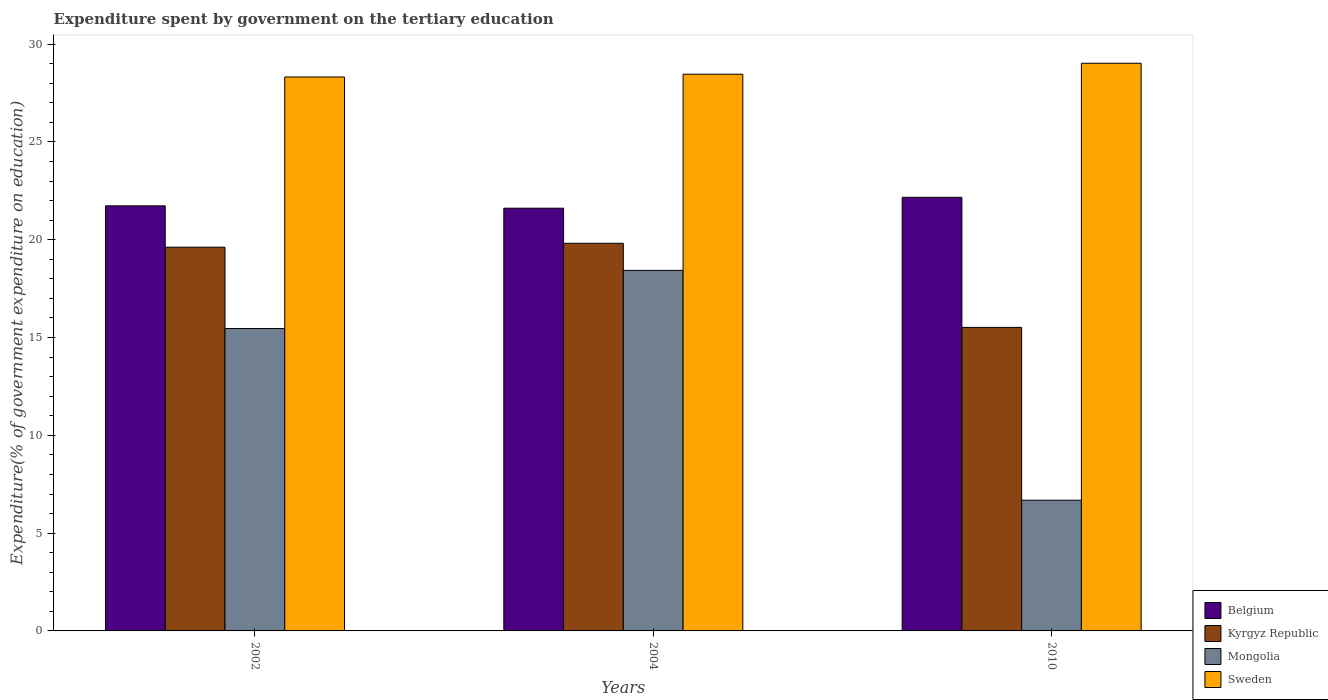How many groups of bars are there?
Give a very brief answer. 3. Are the number of bars per tick equal to the number of legend labels?
Offer a very short reply. Yes. How many bars are there on the 2nd tick from the left?
Provide a short and direct response. 4. How many bars are there on the 3rd tick from the right?
Your answer should be compact. 4. What is the label of the 3rd group of bars from the left?
Your response must be concise. 2010. What is the expenditure spent by government on the tertiary education in Mongolia in 2002?
Your answer should be compact. 15.46. Across all years, what is the maximum expenditure spent by government on the tertiary education in Sweden?
Provide a short and direct response. 29.02. Across all years, what is the minimum expenditure spent by government on the tertiary education in Kyrgyz Republic?
Make the answer very short. 15.52. In which year was the expenditure spent by government on the tertiary education in Mongolia maximum?
Provide a short and direct response. 2004. In which year was the expenditure spent by government on the tertiary education in Sweden minimum?
Ensure brevity in your answer.  2002. What is the total expenditure spent by government on the tertiary education in Belgium in the graph?
Your answer should be very brief. 65.51. What is the difference between the expenditure spent by government on the tertiary education in Belgium in 2002 and that in 2010?
Your answer should be very brief. -0.44. What is the difference between the expenditure spent by government on the tertiary education in Sweden in 2010 and the expenditure spent by government on the tertiary education in Kyrgyz Republic in 2004?
Keep it short and to the point. 9.2. What is the average expenditure spent by government on the tertiary education in Kyrgyz Republic per year?
Your response must be concise. 18.32. In the year 2004, what is the difference between the expenditure spent by government on the tertiary education in Belgium and expenditure spent by government on the tertiary education in Mongolia?
Make the answer very short. 3.18. What is the ratio of the expenditure spent by government on the tertiary education in Sweden in 2004 to that in 2010?
Provide a succinct answer. 0.98. Is the expenditure spent by government on the tertiary education in Sweden in 2002 less than that in 2004?
Give a very brief answer. Yes. Is the difference between the expenditure spent by government on the tertiary education in Belgium in 2002 and 2010 greater than the difference between the expenditure spent by government on the tertiary education in Mongolia in 2002 and 2010?
Provide a short and direct response. No. What is the difference between the highest and the second highest expenditure spent by government on the tertiary education in Belgium?
Keep it short and to the point. 0.44. What is the difference between the highest and the lowest expenditure spent by government on the tertiary education in Sweden?
Offer a terse response. 0.7. In how many years, is the expenditure spent by government on the tertiary education in Kyrgyz Republic greater than the average expenditure spent by government on the tertiary education in Kyrgyz Republic taken over all years?
Offer a very short reply. 2. Is it the case that in every year, the sum of the expenditure spent by government on the tertiary education in Belgium and expenditure spent by government on the tertiary education in Kyrgyz Republic is greater than the sum of expenditure spent by government on the tertiary education in Sweden and expenditure spent by government on the tertiary education in Mongolia?
Give a very brief answer. Yes. What does the 1st bar from the left in 2010 represents?
Offer a very short reply. Belgium. What does the 2nd bar from the right in 2004 represents?
Make the answer very short. Mongolia. Are all the bars in the graph horizontal?
Provide a short and direct response. No. How many years are there in the graph?
Your response must be concise. 3. Are the values on the major ticks of Y-axis written in scientific E-notation?
Your answer should be compact. No. Does the graph contain any zero values?
Your answer should be compact. No. What is the title of the graph?
Give a very brief answer. Expenditure spent by government on the tertiary education. Does "Aruba" appear as one of the legend labels in the graph?
Make the answer very short. No. What is the label or title of the Y-axis?
Your response must be concise. Expenditure(% of government expenditure on education). What is the Expenditure(% of government expenditure on education) of Belgium in 2002?
Make the answer very short. 21.73. What is the Expenditure(% of government expenditure on education) of Kyrgyz Republic in 2002?
Make the answer very short. 19.62. What is the Expenditure(% of government expenditure on education) of Mongolia in 2002?
Your response must be concise. 15.46. What is the Expenditure(% of government expenditure on education) in Sweden in 2002?
Offer a very short reply. 28.32. What is the Expenditure(% of government expenditure on education) of Belgium in 2004?
Give a very brief answer. 21.61. What is the Expenditure(% of government expenditure on education) of Kyrgyz Republic in 2004?
Provide a short and direct response. 19.82. What is the Expenditure(% of government expenditure on education) of Mongolia in 2004?
Keep it short and to the point. 18.43. What is the Expenditure(% of government expenditure on education) of Sweden in 2004?
Provide a succinct answer. 28.46. What is the Expenditure(% of government expenditure on education) in Belgium in 2010?
Offer a very short reply. 22.17. What is the Expenditure(% of government expenditure on education) of Kyrgyz Republic in 2010?
Offer a very short reply. 15.52. What is the Expenditure(% of government expenditure on education) in Mongolia in 2010?
Keep it short and to the point. 6.68. What is the Expenditure(% of government expenditure on education) of Sweden in 2010?
Make the answer very short. 29.02. Across all years, what is the maximum Expenditure(% of government expenditure on education) of Belgium?
Your answer should be very brief. 22.17. Across all years, what is the maximum Expenditure(% of government expenditure on education) in Kyrgyz Republic?
Make the answer very short. 19.82. Across all years, what is the maximum Expenditure(% of government expenditure on education) of Mongolia?
Keep it short and to the point. 18.43. Across all years, what is the maximum Expenditure(% of government expenditure on education) of Sweden?
Your answer should be very brief. 29.02. Across all years, what is the minimum Expenditure(% of government expenditure on education) of Belgium?
Keep it short and to the point. 21.61. Across all years, what is the minimum Expenditure(% of government expenditure on education) of Kyrgyz Republic?
Make the answer very short. 15.52. Across all years, what is the minimum Expenditure(% of government expenditure on education) of Mongolia?
Give a very brief answer. 6.68. Across all years, what is the minimum Expenditure(% of government expenditure on education) in Sweden?
Offer a very short reply. 28.32. What is the total Expenditure(% of government expenditure on education) of Belgium in the graph?
Keep it short and to the point. 65.51. What is the total Expenditure(% of government expenditure on education) of Kyrgyz Republic in the graph?
Your answer should be very brief. 54.95. What is the total Expenditure(% of government expenditure on education) in Mongolia in the graph?
Provide a short and direct response. 40.57. What is the total Expenditure(% of government expenditure on education) in Sweden in the graph?
Keep it short and to the point. 85.8. What is the difference between the Expenditure(% of government expenditure on education) of Belgium in 2002 and that in 2004?
Offer a terse response. 0.12. What is the difference between the Expenditure(% of government expenditure on education) of Kyrgyz Republic in 2002 and that in 2004?
Offer a terse response. -0.2. What is the difference between the Expenditure(% of government expenditure on education) in Mongolia in 2002 and that in 2004?
Keep it short and to the point. -2.97. What is the difference between the Expenditure(% of government expenditure on education) of Sweden in 2002 and that in 2004?
Provide a succinct answer. -0.14. What is the difference between the Expenditure(% of government expenditure on education) in Belgium in 2002 and that in 2010?
Keep it short and to the point. -0.44. What is the difference between the Expenditure(% of government expenditure on education) of Kyrgyz Republic in 2002 and that in 2010?
Ensure brevity in your answer.  4.1. What is the difference between the Expenditure(% of government expenditure on education) in Mongolia in 2002 and that in 2010?
Provide a succinct answer. 8.78. What is the difference between the Expenditure(% of government expenditure on education) in Sweden in 2002 and that in 2010?
Offer a terse response. -0.7. What is the difference between the Expenditure(% of government expenditure on education) in Belgium in 2004 and that in 2010?
Your response must be concise. -0.56. What is the difference between the Expenditure(% of government expenditure on education) in Kyrgyz Republic in 2004 and that in 2010?
Your answer should be very brief. 4.3. What is the difference between the Expenditure(% of government expenditure on education) in Mongolia in 2004 and that in 2010?
Offer a very short reply. 11.75. What is the difference between the Expenditure(% of government expenditure on education) in Sweden in 2004 and that in 2010?
Your answer should be very brief. -0.56. What is the difference between the Expenditure(% of government expenditure on education) in Belgium in 2002 and the Expenditure(% of government expenditure on education) in Kyrgyz Republic in 2004?
Provide a short and direct response. 1.91. What is the difference between the Expenditure(% of government expenditure on education) of Belgium in 2002 and the Expenditure(% of government expenditure on education) of Mongolia in 2004?
Provide a succinct answer. 3.3. What is the difference between the Expenditure(% of government expenditure on education) of Belgium in 2002 and the Expenditure(% of government expenditure on education) of Sweden in 2004?
Your answer should be very brief. -6.73. What is the difference between the Expenditure(% of government expenditure on education) in Kyrgyz Republic in 2002 and the Expenditure(% of government expenditure on education) in Mongolia in 2004?
Give a very brief answer. 1.19. What is the difference between the Expenditure(% of government expenditure on education) of Kyrgyz Republic in 2002 and the Expenditure(% of government expenditure on education) of Sweden in 2004?
Your answer should be compact. -8.84. What is the difference between the Expenditure(% of government expenditure on education) of Mongolia in 2002 and the Expenditure(% of government expenditure on education) of Sweden in 2004?
Offer a very short reply. -13. What is the difference between the Expenditure(% of government expenditure on education) in Belgium in 2002 and the Expenditure(% of government expenditure on education) in Kyrgyz Republic in 2010?
Your response must be concise. 6.21. What is the difference between the Expenditure(% of government expenditure on education) of Belgium in 2002 and the Expenditure(% of government expenditure on education) of Mongolia in 2010?
Your response must be concise. 15.05. What is the difference between the Expenditure(% of government expenditure on education) of Belgium in 2002 and the Expenditure(% of government expenditure on education) of Sweden in 2010?
Your answer should be very brief. -7.29. What is the difference between the Expenditure(% of government expenditure on education) of Kyrgyz Republic in 2002 and the Expenditure(% of government expenditure on education) of Mongolia in 2010?
Keep it short and to the point. 12.94. What is the difference between the Expenditure(% of government expenditure on education) of Kyrgyz Republic in 2002 and the Expenditure(% of government expenditure on education) of Sweden in 2010?
Give a very brief answer. -9.4. What is the difference between the Expenditure(% of government expenditure on education) in Mongolia in 2002 and the Expenditure(% of government expenditure on education) in Sweden in 2010?
Provide a succinct answer. -13.56. What is the difference between the Expenditure(% of government expenditure on education) of Belgium in 2004 and the Expenditure(% of government expenditure on education) of Kyrgyz Republic in 2010?
Make the answer very short. 6.1. What is the difference between the Expenditure(% of government expenditure on education) of Belgium in 2004 and the Expenditure(% of government expenditure on education) of Mongolia in 2010?
Offer a very short reply. 14.93. What is the difference between the Expenditure(% of government expenditure on education) in Belgium in 2004 and the Expenditure(% of government expenditure on education) in Sweden in 2010?
Give a very brief answer. -7.41. What is the difference between the Expenditure(% of government expenditure on education) of Kyrgyz Republic in 2004 and the Expenditure(% of government expenditure on education) of Mongolia in 2010?
Keep it short and to the point. 13.13. What is the difference between the Expenditure(% of government expenditure on education) in Kyrgyz Republic in 2004 and the Expenditure(% of government expenditure on education) in Sweden in 2010?
Ensure brevity in your answer.  -9.2. What is the difference between the Expenditure(% of government expenditure on education) in Mongolia in 2004 and the Expenditure(% of government expenditure on education) in Sweden in 2010?
Give a very brief answer. -10.59. What is the average Expenditure(% of government expenditure on education) of Belgium per year?
Give a very brief answer. 21.84. What is the average Expenditure(% of government expenditure on education) in Kyrgyz Republic per year?
Offer a terse response. 18.32. What is the average Expenditure(% of government expenditure on education) of Mongolia per year?
Offer a terse response. 13.52. What is the average Expenditure(% of government expenditure on education) of Sweden per year?
Give a very brief answer. 28.6. In the year 2002, what is the difference between the Expenditure(% of government expenditure on education) in Belgium and Expenditure(% of government expenditure on education) in Kyrgyz Republic?
Your answer should be very brief. 2.11. In the year 2002, what is the difference between the Expenditure(% of government expenditure on education) in Belgium and Expenditure(% of government expenditure on education) in Mongolia?
Provide a short and direct response. 6.27. In the year 2002, what is the difference between the Expenditure(% of government expenditure on education) in Belgium and Expenditure(% of government expenditure on education) in Sweden?
Your answer should be very brief. -6.59. In the year 2002, what is the difference between the Expenditure(% of government expenditure on education) in Kyrgyz Republic and Expenditure(% of government expenditure on education) in Mongolia?
Keep it short and to the point. 4.16. In the year 2002, what is the difference between the Expenditure(% of government expenditure on education) in Kyrgyz Republic and Expenditure(% of government expenditure on education) in Sweden?
Give a very brief answer. -8.7. In the year 2002, what is the difference between the Expenditure(% of government expenditure on education) in Mongolia and Expenditure(% of government expenditure on education) in Sweden?
Your answer should be compact. -12.86. In the year 2004, what is the difference between the Expenditure(% of government expenditure on education) of Belgium and Expenditure(% of government expenditure on education) of Kyrgyz Republic?
Provide a short and direct response. 1.79. In the year 2004, what is the difference between the Expenditure(% of government expenditure on education) in Belgium and Expenditure(% of government expenditure on education) in Mongolia?
Give a very brief answer. 3.18. In the year 2004, what is the difference between the Expenditure(% of government expenditure on education) in Belgium and Expenditure(% of government expenditure on education) in Sweden?
Your answer should be very brief. -6.85. In the year 2004, what is the difference between the Expenditure(% of government expenditure on education) of Kyrgyz Republic and Expenditure(% of government expenditure on education) of Mongolia?
Ensure brevity in your answer.  1.38. In the year 2004, what is the difference between the Expenditure(% of government expenditure on education) in Kyrgyz Republic and Expenditure(% of government expenditure on education) in Sweden?
Ensure brevity in your answer.  -8.64. In the year 2004, what is the difference between the Expenditure(% of government expenditure on education) of Mongolia and Expenditure(% of government expenditure on education) of Sweden?
Provide a short and direct response. -10.03. In the year 2010, what is the difference between the Expenditure(% of government expenditure on education) in Belgium and Expenditure(% of government expenditure on education) in Kyrgyz Republic?
Your response must be concise. 6.65. In the year 2010, what is the difference between the Expenditure(% of government expenditure on education) of Belgium and Expenditure(% of government expenditure on education) of Mongolia?
Provide a short and direct response. 15.49. In the year 2010, what is the difference between the Expenditure(% of government expenditure on education) in Belgium and Expenditure(% of government expenditure on education) in Sweden?
Your response must be concise. -6.85. In the year 2010, what is the difference between the Expenditure(% of government expenditure on education) in Kyrgyz Republic and Expenditure(% of government expenditure on education) in Mongolia?
Your response must be concise. 8.83. In the year 2010, what is the difference between the Expenditure(% of government expenditure on education) of Kyrgyz Republic and Expenditure(% of government expenditure on education) of Sweden?
Make the answer very short. -13.51. In the year 2010, what is the difference between the Expenditure(% of government expenditure on education) in Mongolia and Expenditure(% of government expenditure on education) in Sweden?
Keep it short and to the point. -22.34. What is the ratio of the Expenditure(% of government expenditure on education) of Belgium in 2002 to that in 2004?
Give a very brief answer. 1.01. What is the ratio of the Expenditure(% of government expenditure on education) in Mongolia in 2002 to that in 2004?
Ensure brevity in your answer.  0.84. What is the ratio of the Expenditure(% of government expenditure on education) in Sweden in 2002 to that in 2004?
Offer a very short reply. 0.99. What is the ratio of the Expenditure(% of government expenditure on education) of Belgium in 2002 to that in 2010?
Ensure brevity in your answer.  0.98. What is the ratio of the Expenditure(% of government expenditure on education) of Kyrgyz Republic in 2002 to that in 2010?
Make the answer very short. 1.26. What is the ratio of the Expenditure(% of government expenditure on education) of Mongolia in 2002 to that in 2010?
Keep it short and to the point. 2.31. What is the ratio of the Expenditure(% of government expenditure on education) of Sweden in 2002 to that in 2010?
Give a very brief answer. 0.98. What is the ratio of the Expenditure(% of government expenditure on education) in Belgium in 2004 to that in 2010?
Provide a succinct answer. 0.97. What is the ratio of the Expenditure(% of government expenditure on education) of Kyrgyz Republic in 2004 to that in 2010?
Make the answer very short. 1.28. What is the ratio of the Expenditure(% of government expenditure on education) in Mongolia in 2004 to that in 2010?
Provide a short and direct response. 2.76. What is the ratio of the Expenditure(% of government expenditure on education) in Sweden in 2004 to that in 2010?
Keep it short and to the point. 0.98. What is the difference between the highest and the second highest Expenditure(% of government expenditure on education) in Belgium?
Keep it short and to the point. 0.44. What is the difference between the highest and the second highest Expenditure(% of government expenditure on education) in Kyrgyz Republic?
Provide a succinct answer. 0.2. What is the difference between the highest and the second highest Expenditure(% of government expenditure on education) in Mongolia?
Provide a short and direct response. 2.97. What is the difference between the highest and the second highest Expenditure(% of government expenditure on education) of Sweden?
Keep it short and to the point. 0.56. What is the difference between the highest and the lowest Expenditure(% of government expenditure on education) in Belgium?
Provide a succinct answer. 0.56. What is the difference between the highest and the lowest Expenditure(% of government expenditure on education) in Kyrgyz Republic?
Offer a very short reply. 4.3. What is the difference between the highest and the lowest Expenditure(% of government expenditure on education) in Mongolia?
Provide a short and direct response. 11.75. What is the difference between the highest and the lowest Expenditure(% of government expenditure on education) of Sweden?
Offer a terse response. 0.7. 